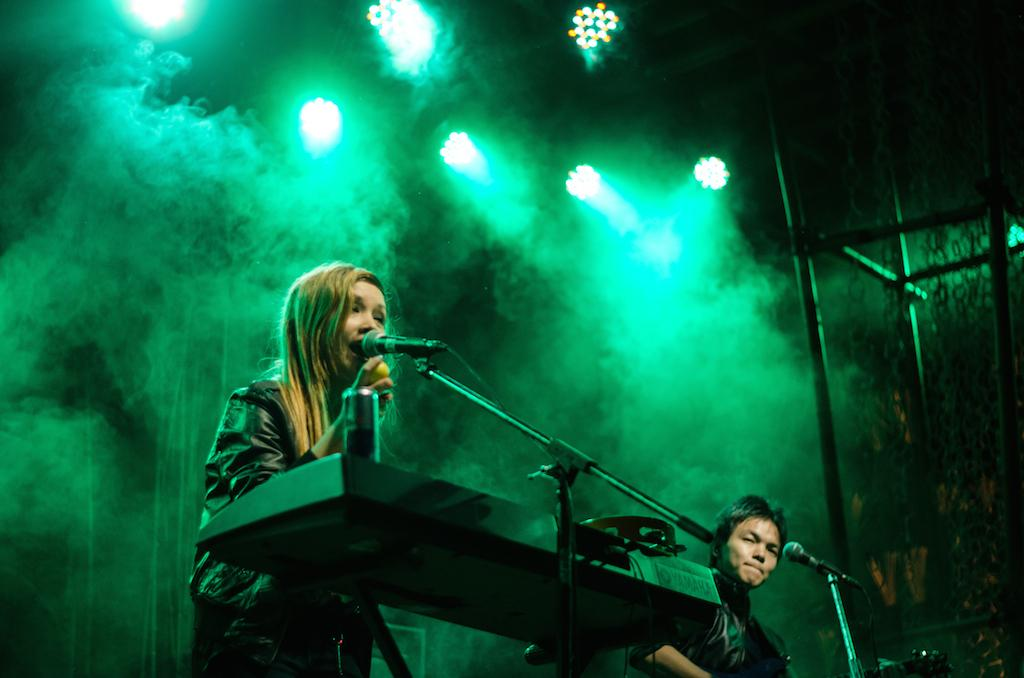How many people are present in the image? There are two people in the image. What objects can be seen in the image besides the people? There are microphones, other objects, a pole stand, chains on the right side, and lights in the image. What type of seed is being planted in the image? There is no seed present in the image. What channel can be seen on the television in the image? There is no television present in the image. 